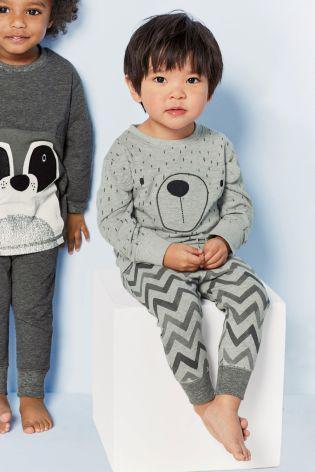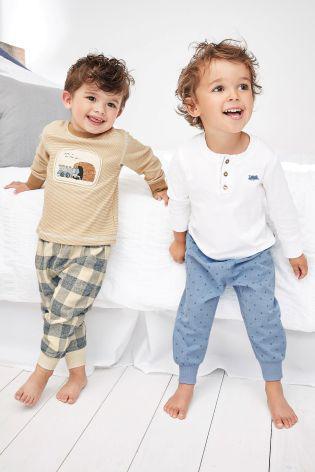The first image is the image on the left, the second image is the image on the right. For the images shown, is this caption "An image shows a child modeling a striped top and bottom." true? Answer yes or no. No. The first image is the image on the left, the second image is the image on the right. Given the left and right images, does the statement "A boy and girl in the image on the left are sitting down." hold true? Answer yes or no. No. 